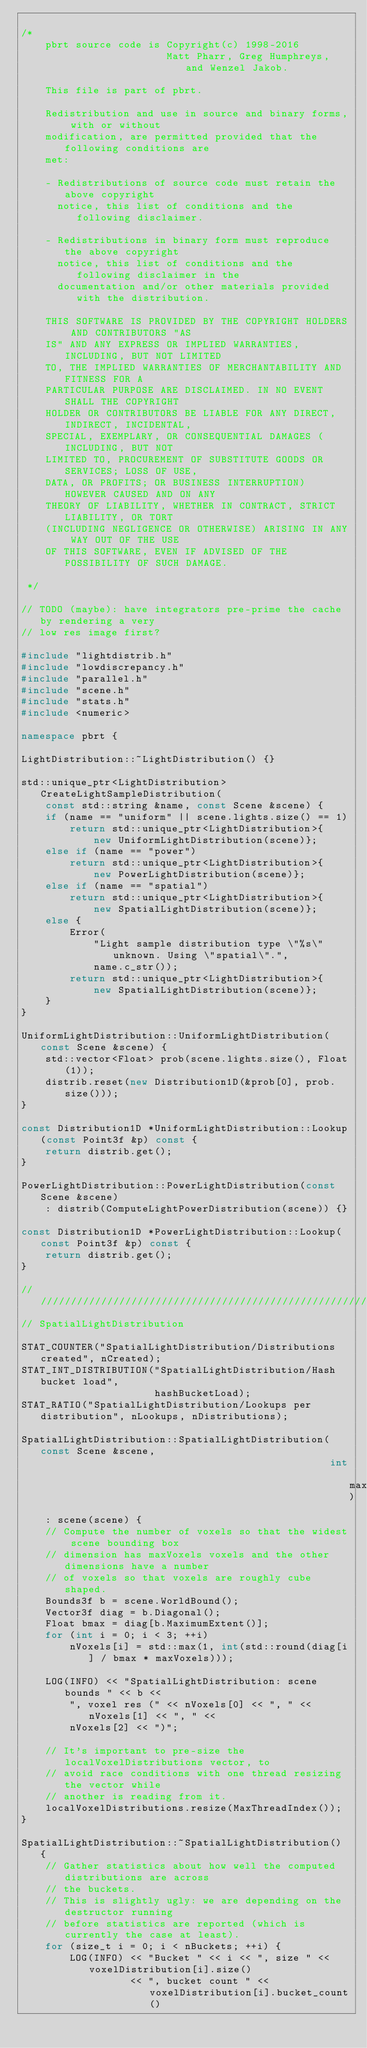Convert code to text. <code><loc_0><loc_0><loc_500><loc_500><_C++_>
/*
    pbrt source code is Copyright(c) 1998-2016
                        Matt Pharr, Greg Humphreys, and Wenzel Jakob.

    This file is part of pbrt.

    Redistribution and use in source and binary forms, with or without
    modification, are permitted provided that the following conditions are
    met:

    - Redistributions of source code must retain the above copyright
      notice, this list of conditions and the following disclaimer.

    - Redistributions in binary form must reproduce the above copyright
      notice, this list of conditions and the following disclaimer in the
      documentation and/or other materials provided with the distribution.

    THIS SOFTWARE IS PROVIDED BY THE COPYRIGHT HOLDERS AND CONTRIBUTORS "AS
    IS" AND ANY EXPRESS OR IMPLIED WARRANTIES, INCLUDING, BUT NOT LIMITED
    TO, THE IMPLIED WARRANTIES OF MERCHANTABILITY AND FITNESS FOR A
    PARTICULAR PURPOSE ARE DISCLAIMED. IN NO EVENT SHALL THE COPYRIGHT
    HOLDER OR CONTRIBUTORS BE LIABLE FOR ANY DIRECT, INDIRECT, INCIDENTAL,
    SPECIAL, EXEMPLARY, OR CONSEQUENTIAL DAMAGES (INCLUDING, BUT NOT
    LIMITED TO, PROCUREMENT OF SUBSTITUTE GOODS OR SERVICES; LOSS OF USE,
    DATA, OR PROFITS; OR BUSINESS INTERRUPTION) HOWEVER CAUSED AND ON ANY
    THEORY OF LIABILITY, WHETHER IN CONTRACT, STRICT LIABILITY, OR TORT
    (INCLUDING NEGLIGENCE OR OTHERWISE) ARISING IN ANY WAY OUT OF THE USE
    OF THIS SOFTWARE, EVEN IF ADVISED OF THE POSSIBILITY OF SUCH DAMAGE.

 */

// TODO (maybe): have integrators pre-prime the cache by rendering a very
// low res image first?

#include "lightdistrib.h"
#include "lowdiscrepancy.h"
#include "parallel.h"
#include "scene.h"
#include "stats.h"
#include <numeric>

namespace pbrt {

LightDistribution::~LightDistribution() {}

std::unique_ptr<LightDistribution> CreateLightSampleDistribution(
    const std::string &name, const Scene &scene) {
    if (name == "uniform" || scene.lights.size() == 1)
        return std::unique_ptr<LightDistribution>{
            new UniformLightDistribution(scene)};
    else if (name == "power")
        return std::unique_ptr<LightDistribution>{
            new PowerLightDistribution(scene)};
    else if (name == "spatial")
        return std::unique_ptr<LightDistribution>{
            new SpatialLightDistribution(scene)};
    else {
        Error(
            "Light sample distribution type \"%s\" unknown. Using \"spatial\".",
            name.c_str());
        return std::unique_ptr<LightDistribution>{
            new SpatialLightDistribution(scene)};
    }
}

UniformLightDistribution::UniformLightDistribution(const Scene &scene) {
    std::vector<Float> prob(scene.lights.size(), Float(1));
    distrib.reset(new Distribution1D(&prob[0], prob.size()));
}

const Distribution1D *UniformLightDistribution::Lookup(const Point3f &p) const {
    return distrib.get();
}

PowerLightDistribution::PowerLightDistribution(const Scene &scene)
    : distrib(ComputeLightPowerDistribution(scene)) {}

const Distribution1D *PowerLightDistribution::Lookup(const Point3f &p) const {
    return distrib.get();
}

///////////////////////////////////////////////////////////////////////////
// SpatialLightDistribution

STAT_COUNTER("SpatialLightDistribution/Distributions created", nCreated);
STAT_INT_DISTRIBUTION("SpatialLightDistribution/Hash bucket load",
                      hashBucketLoad);
STAT_RATIO("SpatialLightDistribution/Lookups per distribution", nLookups, nDistributions);

SpatialLightDistribution::SpatialLightDistribution(const Scene &scene,
                                                   int maxVoxels)
    : scene(scene) {
    // Compute the number of voxels so that the widest scene bounding box
    // dimension has maxVoxels voxels and the other dimensions have a number
    // of voxels so that voxels are roughly cube shaped.
    Bounds3f b = scene.WorldBound();
    Vector3f diag = b.Diagonal();
    Float bmax = diag[b.MaximumExtent()];
    for (int i = 0; i < 3; ++i)
        nVoxels[i] = std::max(1, int(std::round(diag[i] / bmax * maxVoxels)));

    LOG(INFO) << "SpatialLightDistribution: scene bounds " << b <<
        ", voxel res (" << nVoxels[0] << ", " << nVoxels[1] << ", " <<
        nVoxels[2] << ")";

    // It's important to pre-size the localVoxelDistributions vector, to
    // avoid race conditions with one thread resizing the vector while
    // another is reading from it.
    localVoxelDistributions.resize(MaxThreadIndex());
}

SpatialLightDistribution::~SpatialLightDistribution() {
    // Gather statistics about how well the computed distributions are across
    // the buckets.
    // This is slightly ugly: we are depending on the destructor running
    // before statistics are reported (which is currently the case at least).
    for (size_t i = 0; i < nBuckets; ++i) {
        LOG(INFO) << "Bucket " << i << ", size " << voxelDistribution[i].size()
                  << ", bucket count " << voxelDistribution[i].bucket_count()</code> 